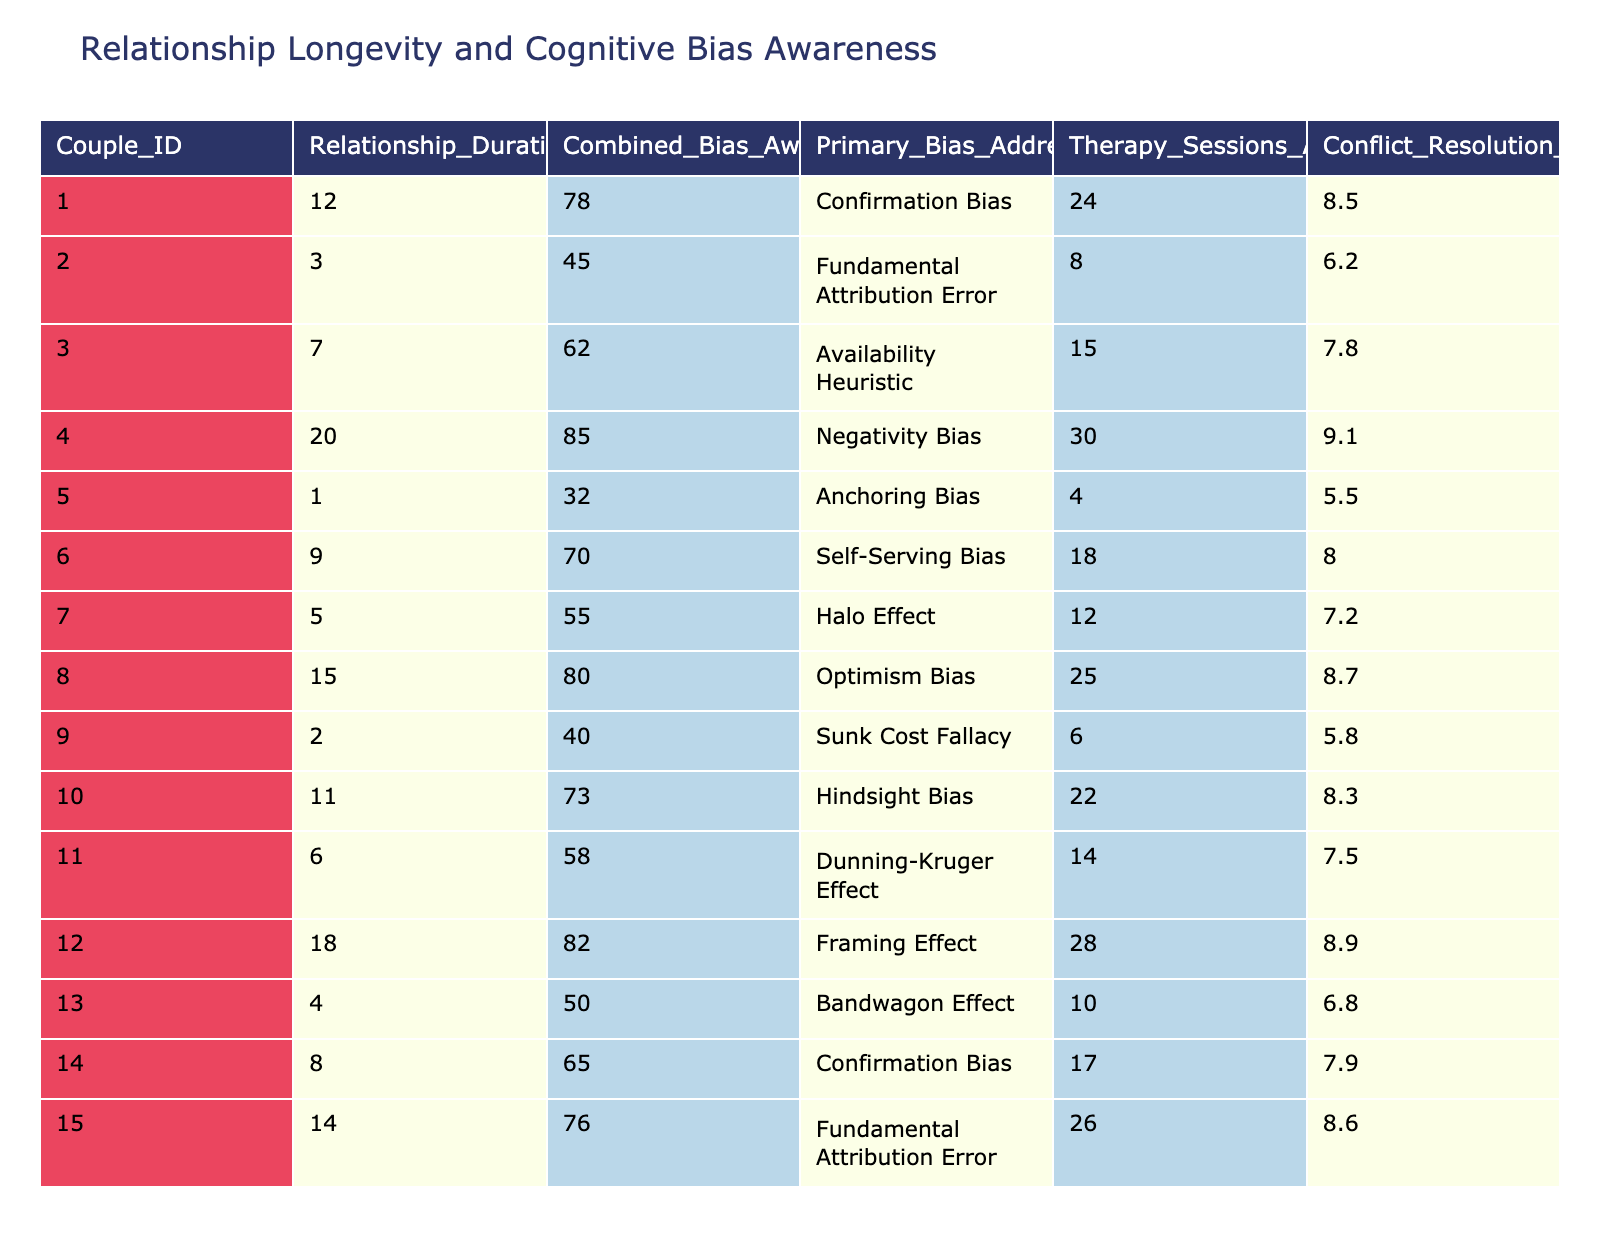What is the relationship duration of Couple 4? In the table, the "Relationship_Duration_Years" column shows that the value for Couple 4 is 20.
Answer: 20 What is the Combined Bias Awareness Score for Couple 3? The table indicates that the "Combined_Bias_Awareness_Score" for Couple 3 is 62.
Answer: 62 Which couple has attended the most therapy sessions? By examining the "Therapy_Sessions_Attended" column, Couple 4 has attended 30 sessions, which is the highest number present in the table.
Answer: Couple 4 What is the average Conflict Resolution Rating for all couples? To find the average, sum up all the ratings (8.5 + 6.2 + 7.8 + 9.1 + 5.5 + 8.0 + 7.2 + 8.7 + 5.8 + 8.3 + 7.5 + 8.9 + 6.8 + 7.9 + 8.6) which equals 123.2, and then divide by the number of couples (15). Average = 123.2/15 = 8.21.
Answer: 8.21 Is there a couple with a Relationship Duration of less than 3 years? Checking the "Relationship_Duration_Years" column, Couple 5 has a duration of 1 year, which is less than 3.
Answer: Yes What is the difference in Combined Bias Awareness Scores between Couple 1 and Couple 5? The "Combined_Bias_Awareness_Score" for Couple 1 is 78 and for Couple 5 is 32. The difference is calculated as 78 - 32 = 46.
Answer: 46 Which couple addressed the Hindsight Bias, and what is their Relationship Duration? The table shows that Couple 10 is addressing Hindsight Bias and their Relationship Duration is 11 years.
Answer: Couple 10, 11 years Calculate the total number of therapy sessions attended by couples exhibiting Negativity Bias and Optimism Bias. From the table, Couple 4 addressed Negativity Bias and attended 30 sessions, while Couple 8 who addressed Optimism Bias attended 25 sessions. The total is 30 + 25 = 55 sessions.
Answer: 55 What can be said about the Conflict Resolution Rating of couples with a combined bias awareness score below 50? Those couples, specifically Couple 5 and Couple 13, have Conflict Resolution Ratings of 5.5 and 6.8, indicating these couples may struggle more with conflict resolution compared to others.
Answer: They have lower ratings Which couple has the highest Combined Bias Awareness Score and what is their Relationship Duration? The highest score is 85 for Couple 4, whose Relationship Duration is 20 years.
Answer: Couple 4, 20 years Do couples with a longer relationship duration generally show higher awareness of cognitive biases? Analyzing the data, it's observed that many couples with longer relationship durations tend to have higher awareness scores, suggesting a correlation exists.
Answer: Yes, generally higher awareness 